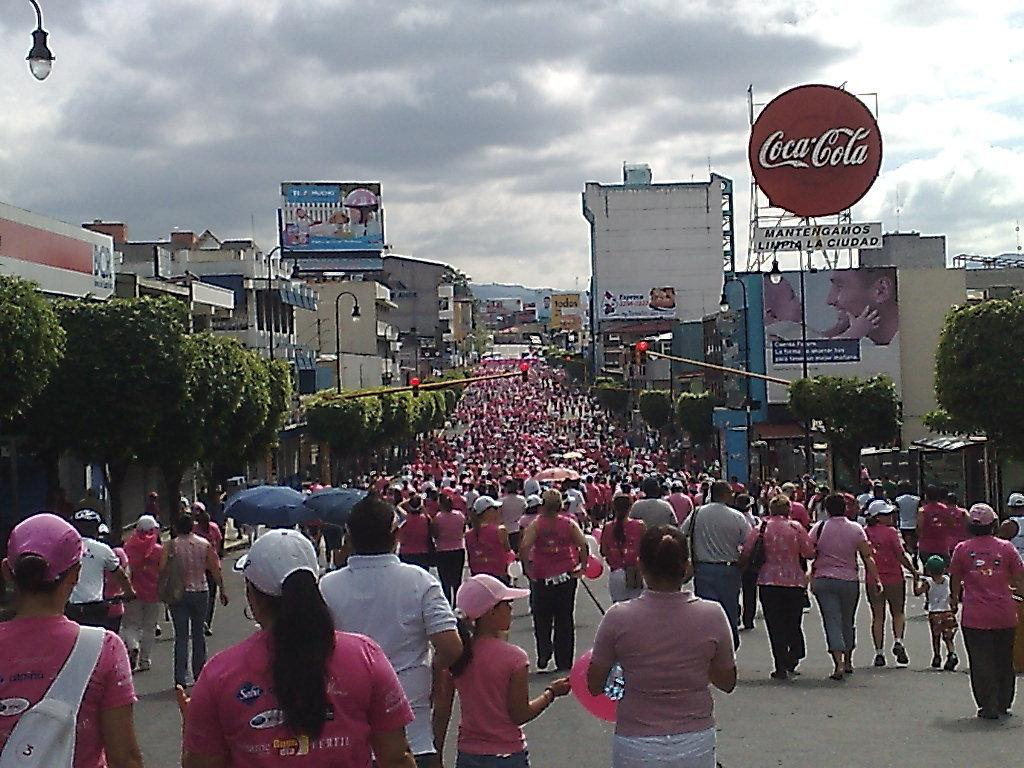How many people are in the group visible in the image? There is a group of people in the image, but the exact number is not specified. What type of natural vegetation can be seen in the image? There are trees in the image. What type of decorations or signage is present in the image? Banners are present in the image. What type of structures are visible in the image? There are buildings in the image. What type of lighting is present in the image? Street lamps are visible in the image. What type of accessory is present in the image for protection against the elements? Umbrellas are in the image. What is visible at the top of the image? The sky is visible at the top of the image. What type of weather condition can be inferred from the sky? Clouds are present in the sky, which suggests that it might be a partly cloudy day. What type of coat is the person wearing in the image? There is no mention of a coat in the image, and no person is described as wearing one. How many items can be found in the pocket of the person in the image? There is no person described as having a pocket in the image. 